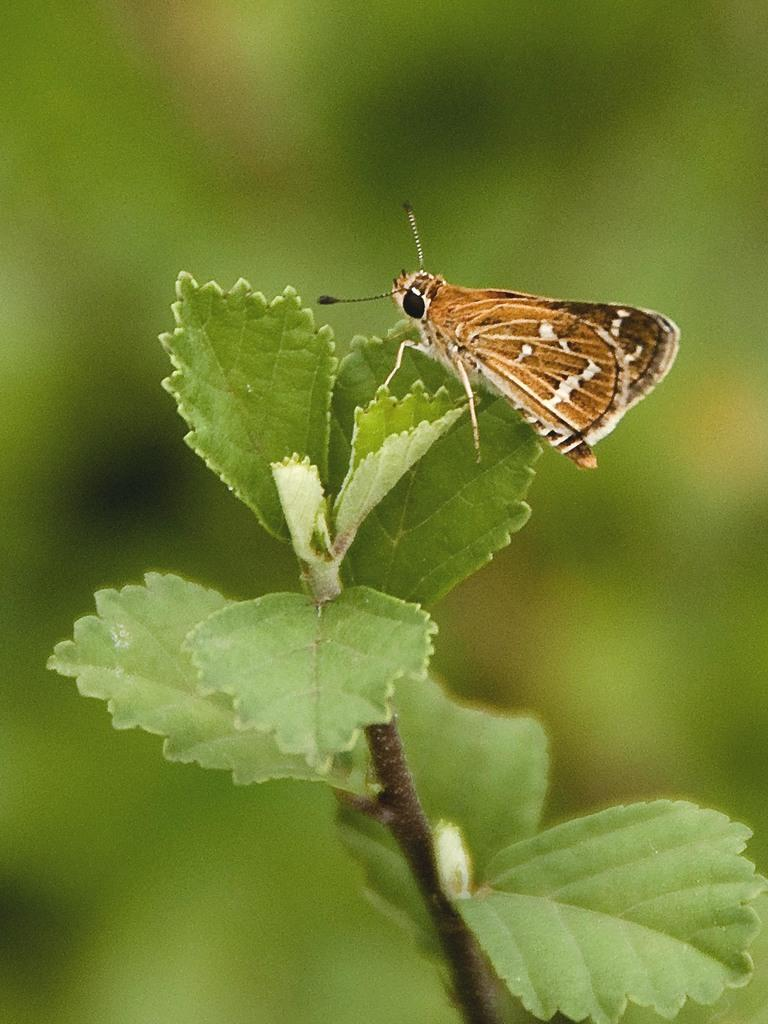What is on the leaf in the image? There is a fly on a leaf in the image. What type of plant is visible at the bottom of the image? There is a plant at the bottom of the image. How many spots can be seen on the sheep in the image? There is no sheep present in the image; it only features a fly on a leaf and a plant. 